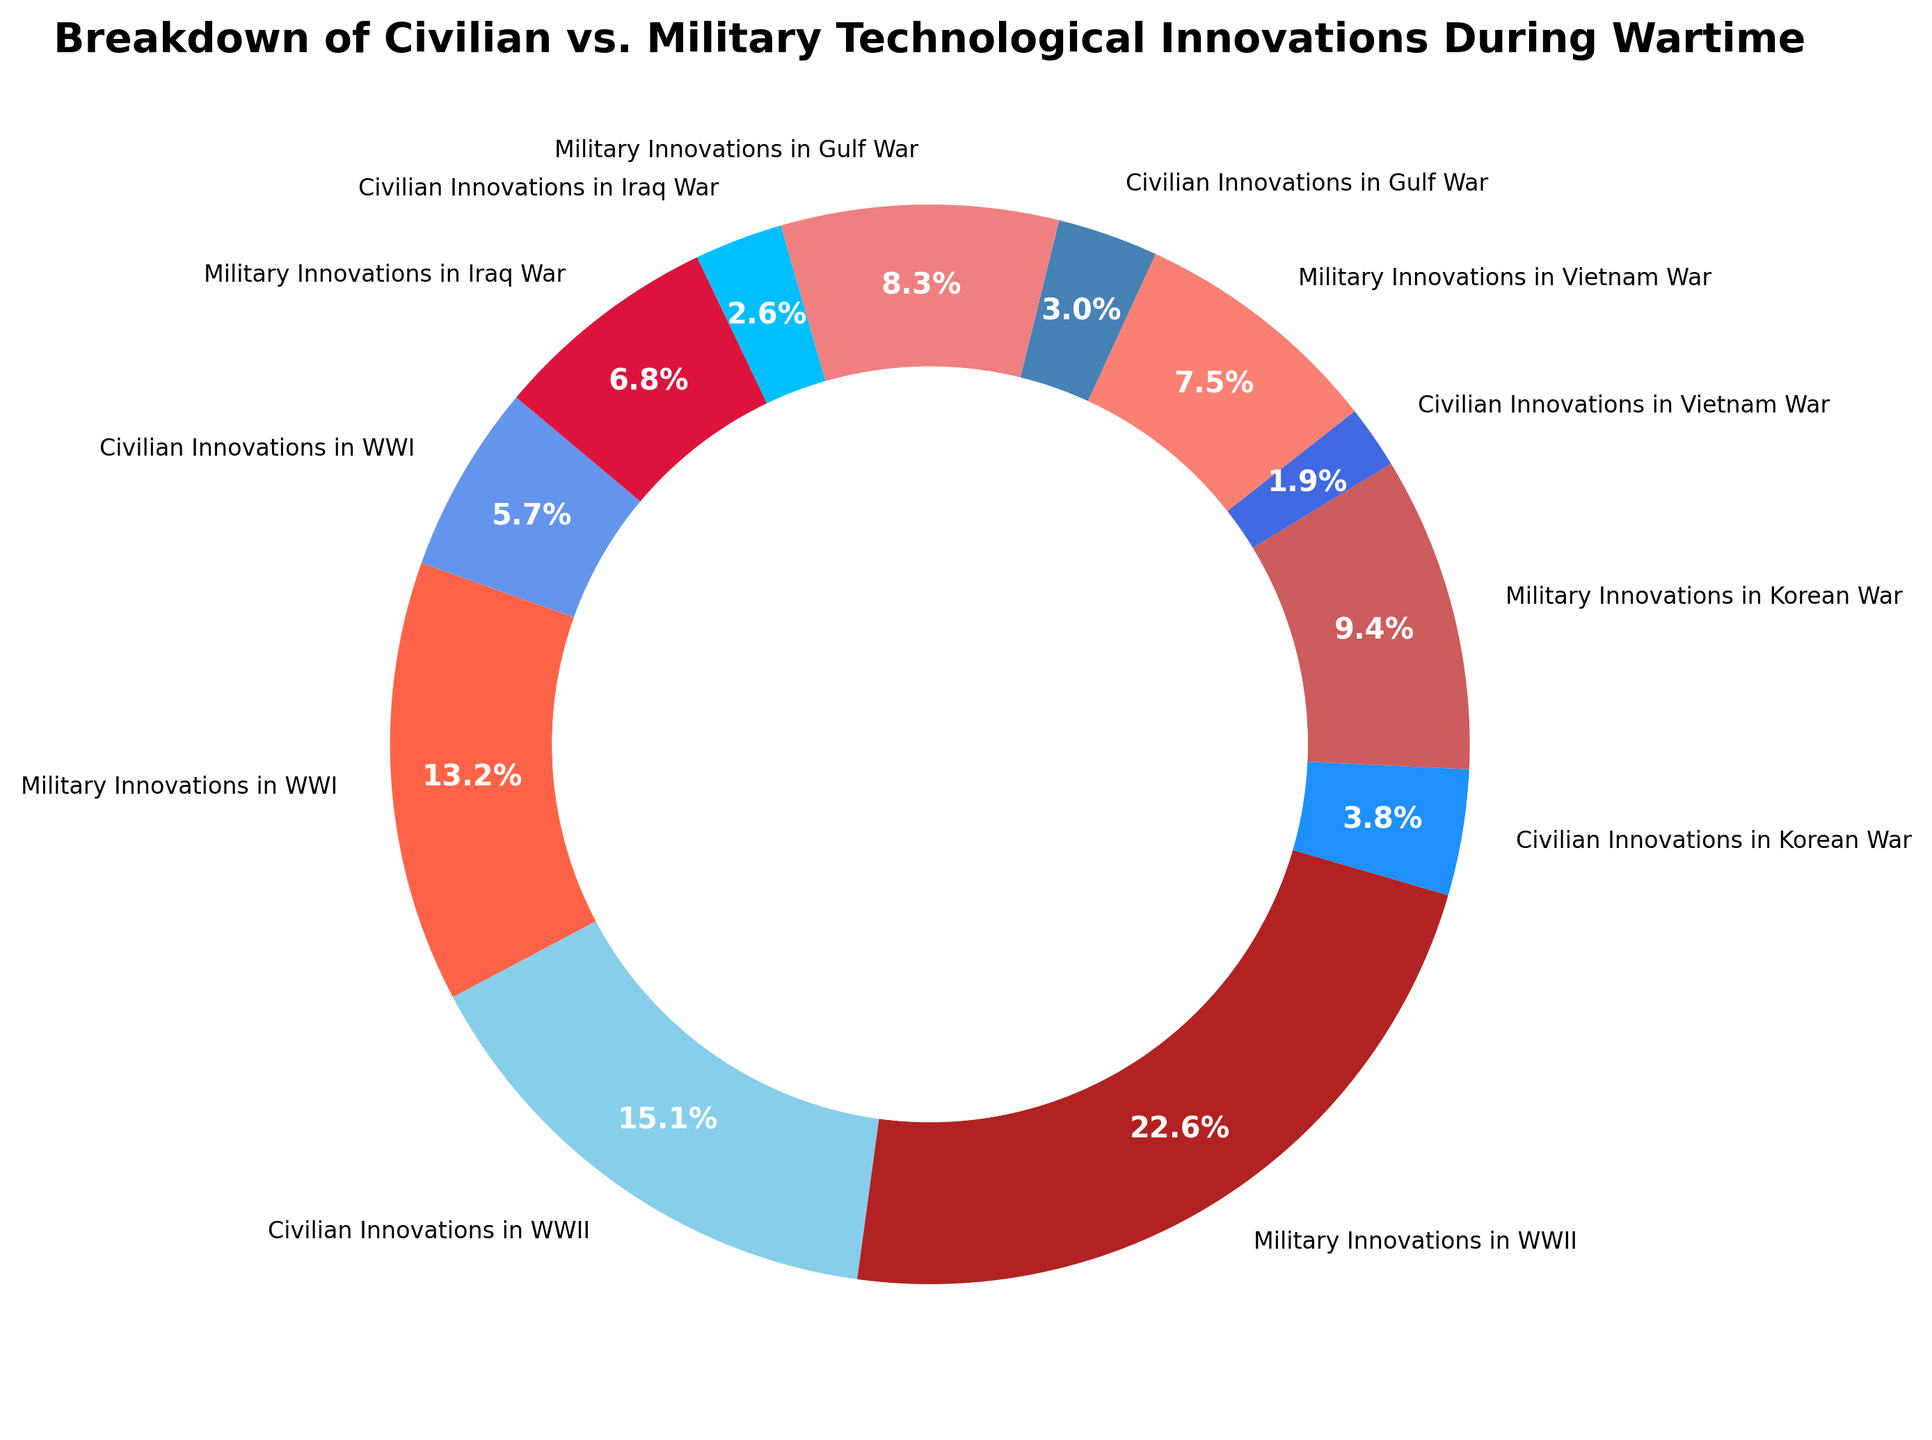Which war period had the highest total number of technological innovations? WWII had the highest total number of technological innovations since adding civilian (40) and military (60) innovations results in 100. This is more than the totals for WWI (50), Korean War (35), Vietnam War (25), Gulf War (30), and Iraq War (25).
Answer: WWII What is the difference between civilian and military innovations during the Korean War? The number of military innovations during the Korean War is 25, while civilian innovations are 10. Taking the difference, we get 25 - 10 = 15.
Answer: 15 Are there more civilian or military innovations during the Gulf War? According to the figure, during the Gulf War there are 8 civilian innovations and 22 military innovations. Therefore, military innovations are more numerous.
Answer: Military Which color represents military innovations in WWII? The color representing military innovations during WWII is a shade of dark red, specifically firebrick.
Answer: Dark red What is the sum of civilian innovations during the Gulf War and Iraq War? Civilian innovations in the Gulf War are 8 and in the Iraq War are 7. Combining these, we get 8 + 7 = 15.
Answer: 15 What is the proportion of civilian innovations to total innovations in the Vietnam War? The total number of innovations during the Vietnam War is 5 (civilian) + 20 (military) = 25. The proportion of civilian innovations is 5/25, which is 20%.
Answer: 20% Which war has the smallest proportion of civilian innovations? Vietnam War has the least civilian innovations proportion since 5 out of 25 (20%), compared to other wars with higher ratios.
Answer: Vietnam War How do the number of military innovations in WWI compare to civilian innovations in WWII? Military innovations in WWI are 35, while civilian innovations in WWII are 40. Since 40 > 35, civilian innovations in WWII are greater.
Answer: Civilian innovations in WWII are greater What is the average number of civilian innovations across all war periods? Adding all civilian innovations: 15 (WWI) + 40 (WWII) + 10 (Korean War) + 5 (Vietnam War) + 8 (Gulf War) + 7 (Iraq War) = 85. There are 6 periods, so average is 85/6 ≈ 14.2.
Answer: 14.2 